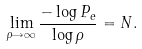Convert formula to latex. <formula><loc_0><loc_0><loc_500><loc_500>\lim _ { \rho \rightarrow \infty } \frac { - \log P _ { e } } { \log \rho } = N .</formula> 